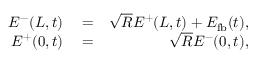Convert formula to latex. <formula><loc_0><loc_0><loc_500><loc_500>\begin{array} { r l r } { E ^ { - } ( L , t ) } & = } & { \sqrt { R } E ^ { + } ( L , t ) + E _ { f b } ( t ) , } \\ { E ^ { + } ( 0 , t ) } & = } & { \sqrt { R } E ^ { - } ( 0 , t ) , } \end{array}</formula> 